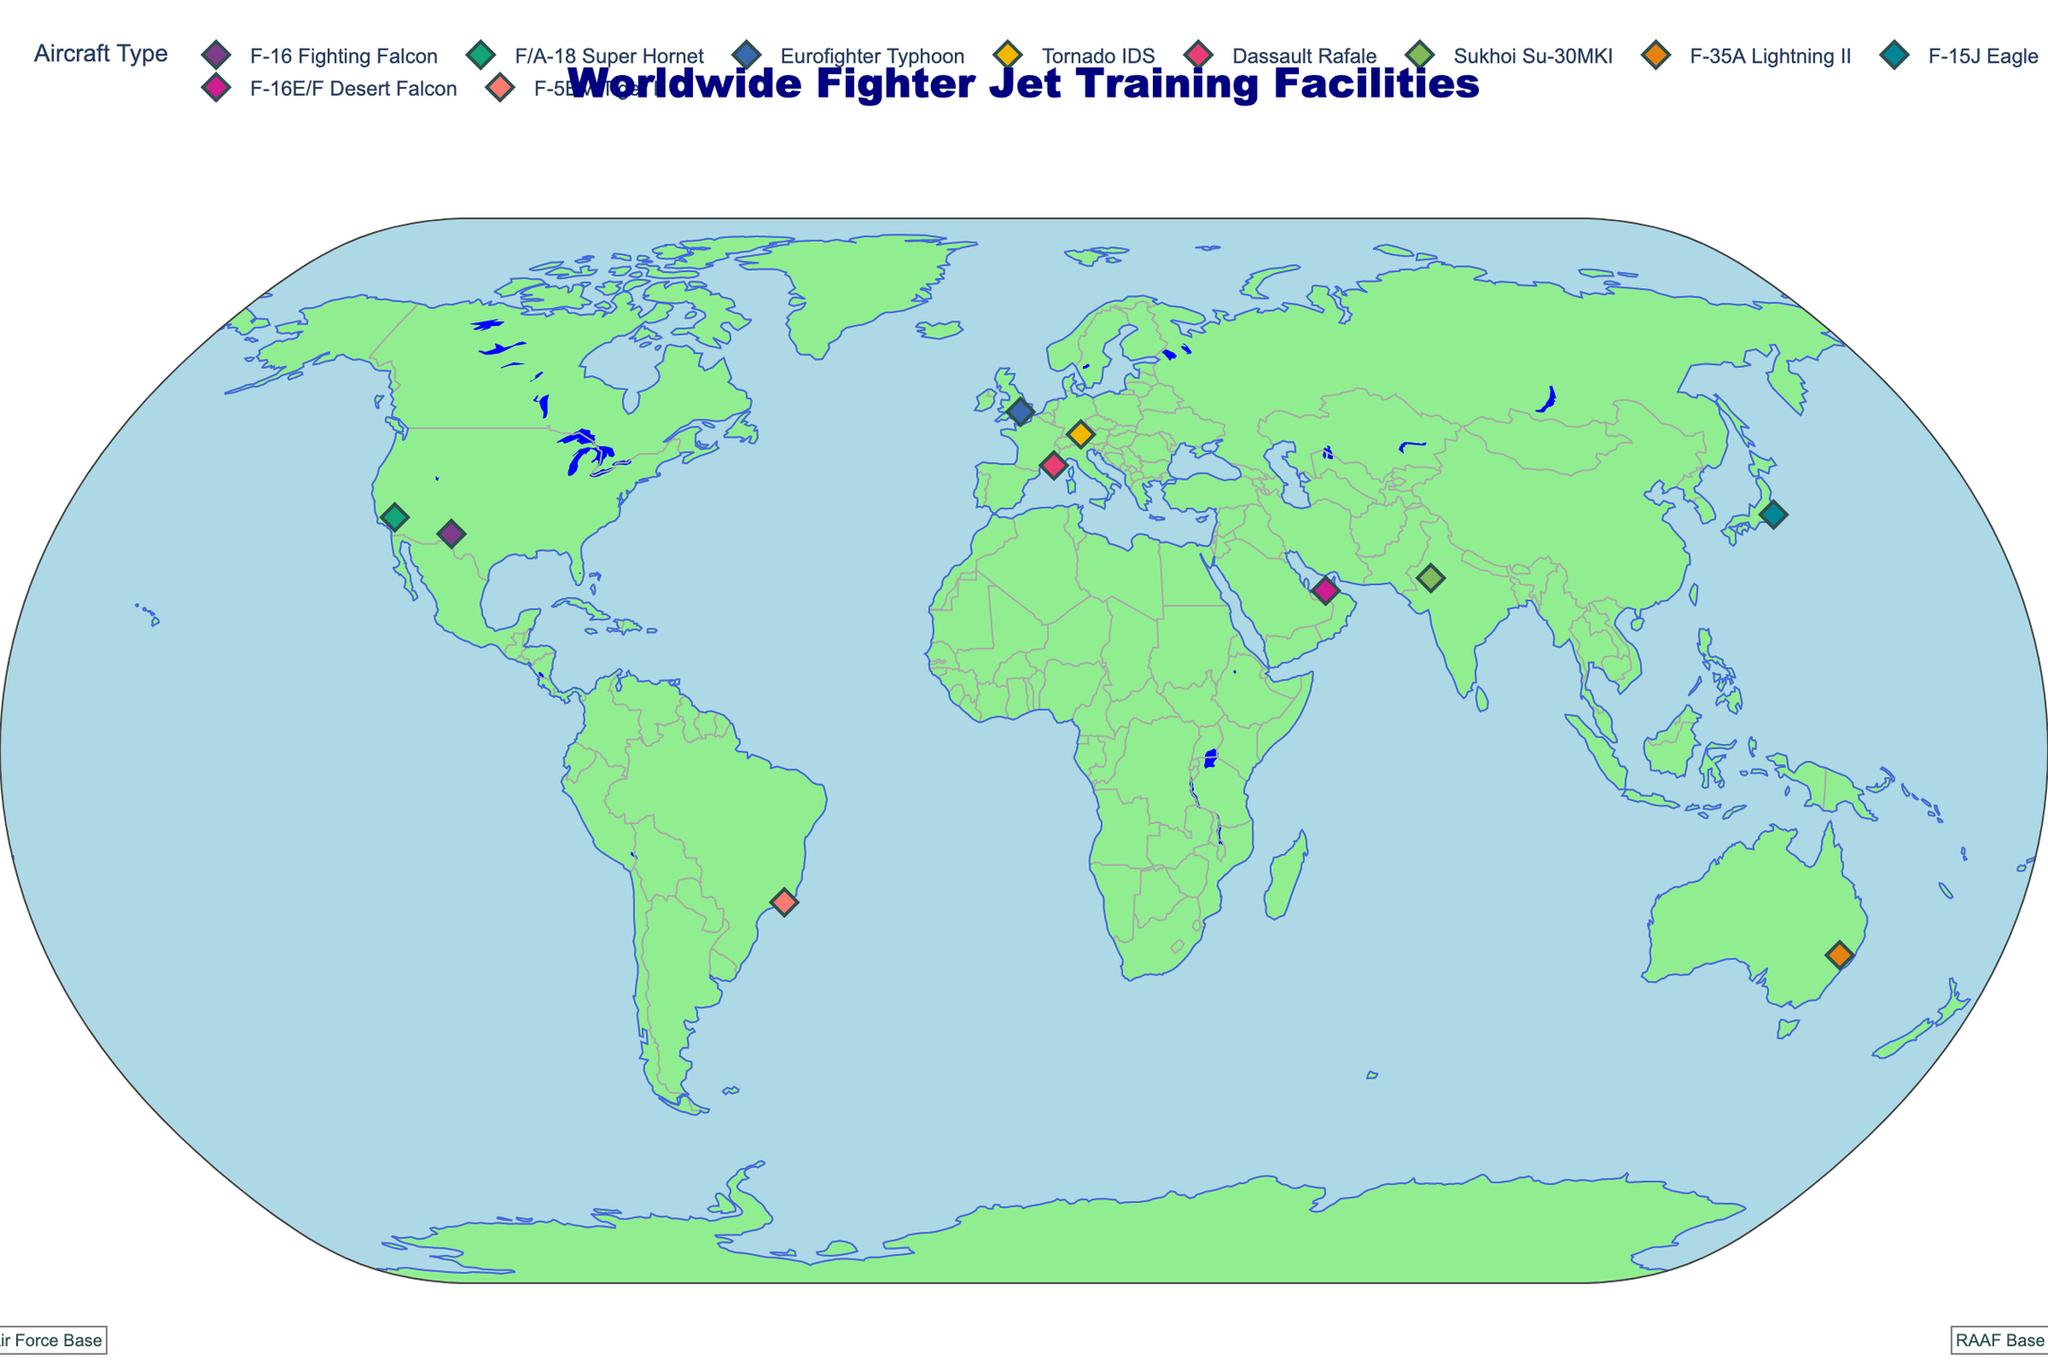What is the title of the figure? The title is generally located at the top of the chart. In this figure, it says 'Worldwide Fighter Jet Training Facilities'.
Answer: Worldwide Fighter Jet Training Facilities How many fighter jet training facilities are shown worldwide? By counting each data point or marker on the map, we can determine the number of facilities. There are 10 markers shown.
Answer: 10 Which country has the training facility with the Eurofighter Typhoon aircraft? We need to look at the markers and hover over the one labeled 'Eurofighter Typhoon' to see the associated country. The country is the UK.
Answer: UK How many training facilities in Asia offer fighter jet training? Identify the markers in the Asian continent and count them. The markers for Asia are in India, Japan, and the UAE, summing up to 3 facilities.
Answer: 3 Which training facility is associated with the 'Fifth Generation Fighter Integration' program, and where is it located? Hover over each marker to check the 'Training_Program' attribute until you find 'Fifth Generation Fighter Integration'. It is at RAAF Base Williamtown in Australia.
Answer: RAAF Base Williamtown in Australia Which two training facilities are closest to each other geographically? Visually analyze the plot to identify the markers in closest proximity. The facilities in the USA (Holloman AFB and Naval Air Weapons Station China Lake) appear closest.
Answer: Holloman AFB and Naval Air Weapons Station China Lake What training program is provided at Santa Cruz Air Force Base in Brazil? Hover over the marker for Santa Cruz Air Force Base and read the 'Training_Program' attribute. It is 'Tactical Fighter Training'.
Answer: Tactical Fighter Training What is the average latitude of the training facilities located in the USA? Identify the latitudes of US facilities (32.8350 at Holloman AFB and 35.3385 at Naval Air Weapons Station China Lake). Calculate the average: (32.8350 + 35.3385) / 2 = 34.08675.
Answer: 34.08675 Which facility offers 'Operational Conversion' training and what aircraft is used there? Find the marker with 'Operational Conversion' and hover over it to check the aircraft type. It is at RAF High Wycombe and uses the Eurofighter Typhoon.
Answer: RAF High Wycombe, Eurofighter Typhoon How many facilities use an F-16 variant of the aircraft for training programs? Look for all markers associated with F-16 variants. Holloman AFB uses F-16 Fighting Falcon and Al Dhafra Air Base uses F-16E/F Desert Falcon. There are 2 facilities.
Answer: 2 